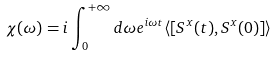<formula> <loc_0><loc_0><loc_500><loc_500>\chi ( \omega ) = i \int _ { 0 } ^ { + \infty } d \omega e ^ { i \omega t } \langle [ S ^ { x } ( t ) , S ^ { x } ( 0 ) ] \rangle</formula> 